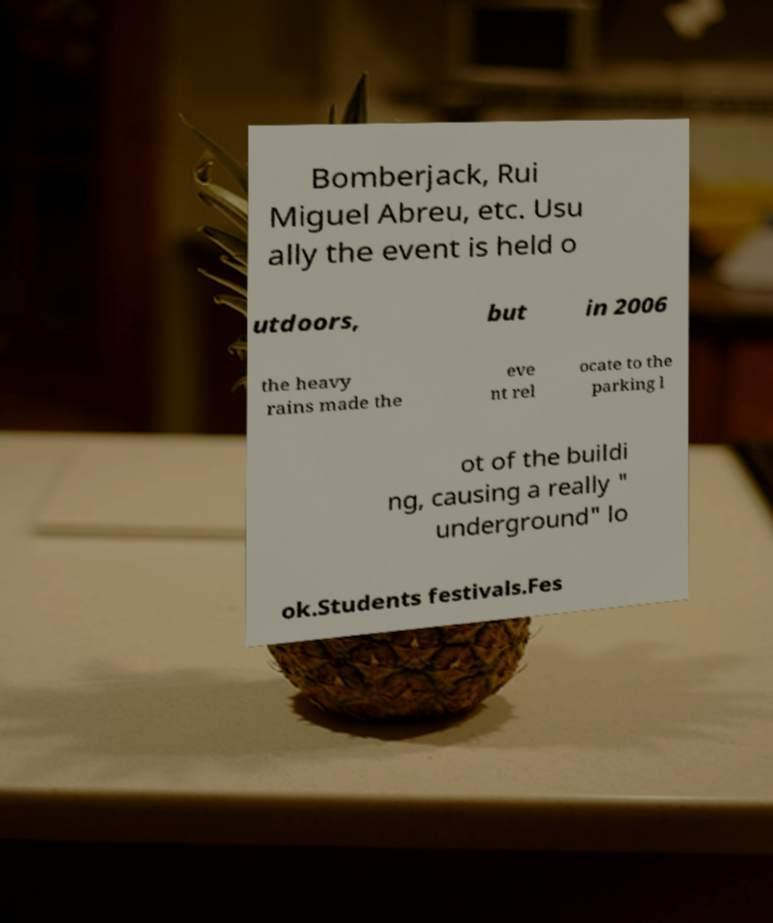There's text embedded in this image that I need extracted. Can you transcribe it verbatim? Bomberjack, Rui Miguel Abreu, etc. Usu ally the event is held o utdoors, but in 2006 the heavy rains made the eve nt rel ocate to the parking l ot of the buildi ng, causing a really " underground" lo ok.Students festivals.Fes 